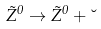<formula> <loc_0><loc_0><loc_500><loc_500>\tilde { Z } ^ { 0 } \rightarrow \tilde { Z } ^ { 0 } + \lambda</formula> 